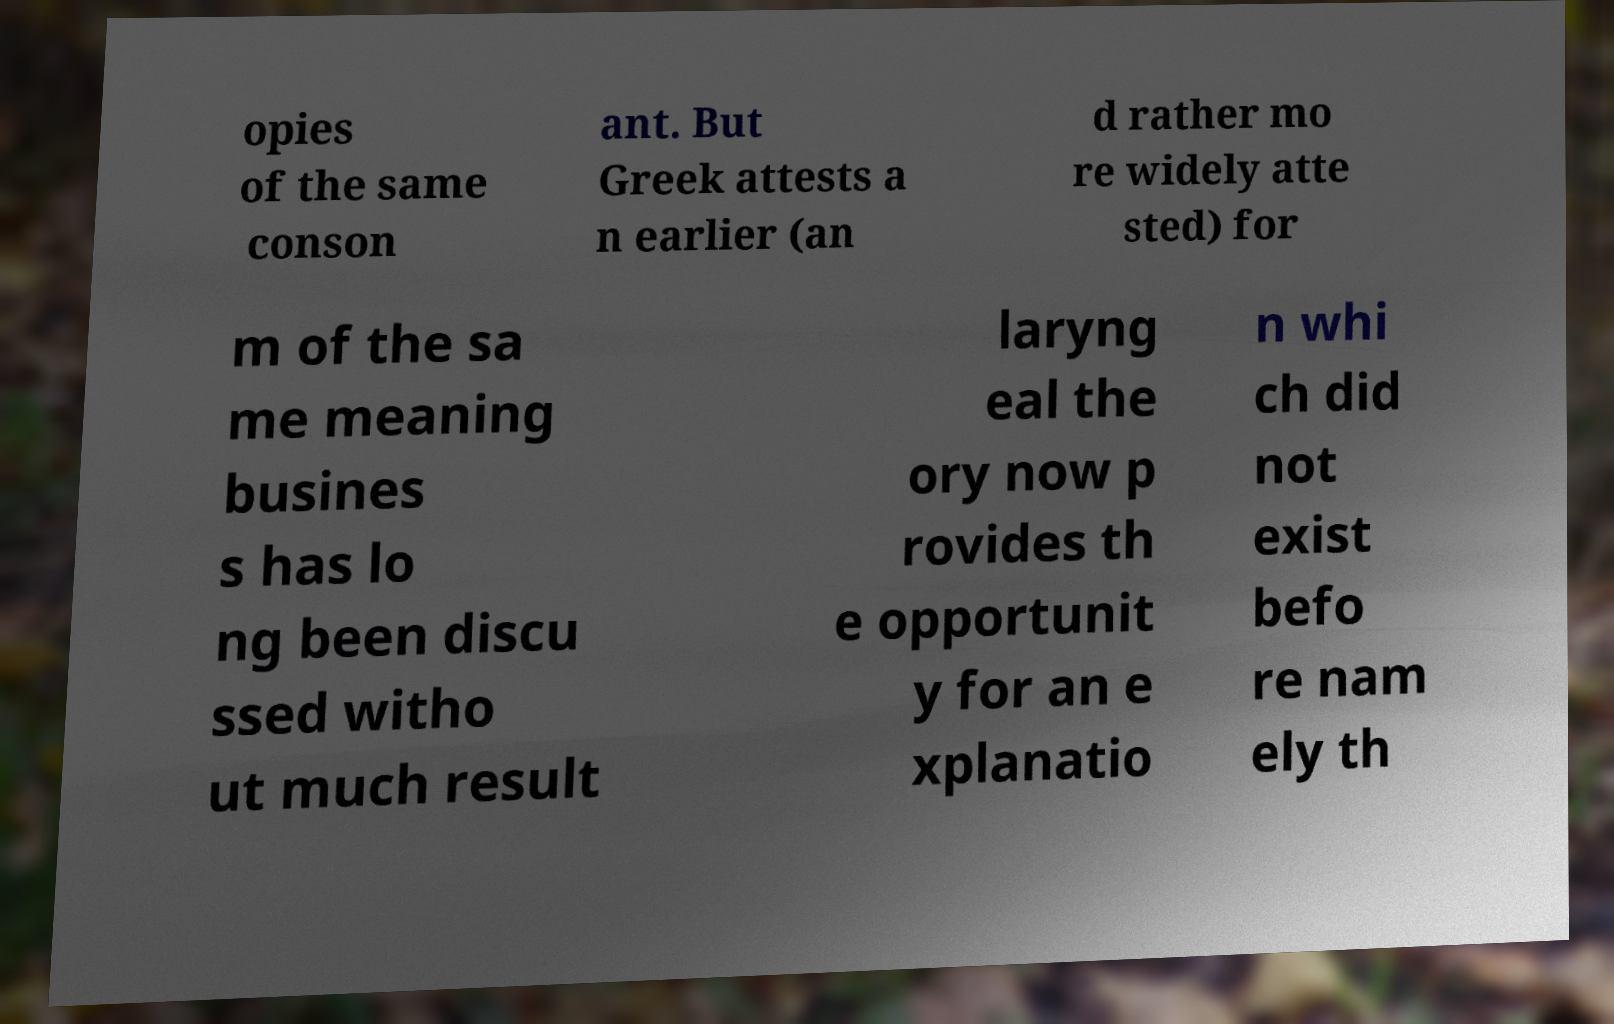I need the written content from this picture converted into text. Can you do that? opies of the same conson ant. But Greek attests a n earlier (an d rather mo re widely atte sted) for m of the sa me meaning busines s has lo ng been discu ssed witho ut much result laryng eal the ory now p rovides th e opportunit y for an e xplanatio n whi ch did not exist befo re nam ely th 